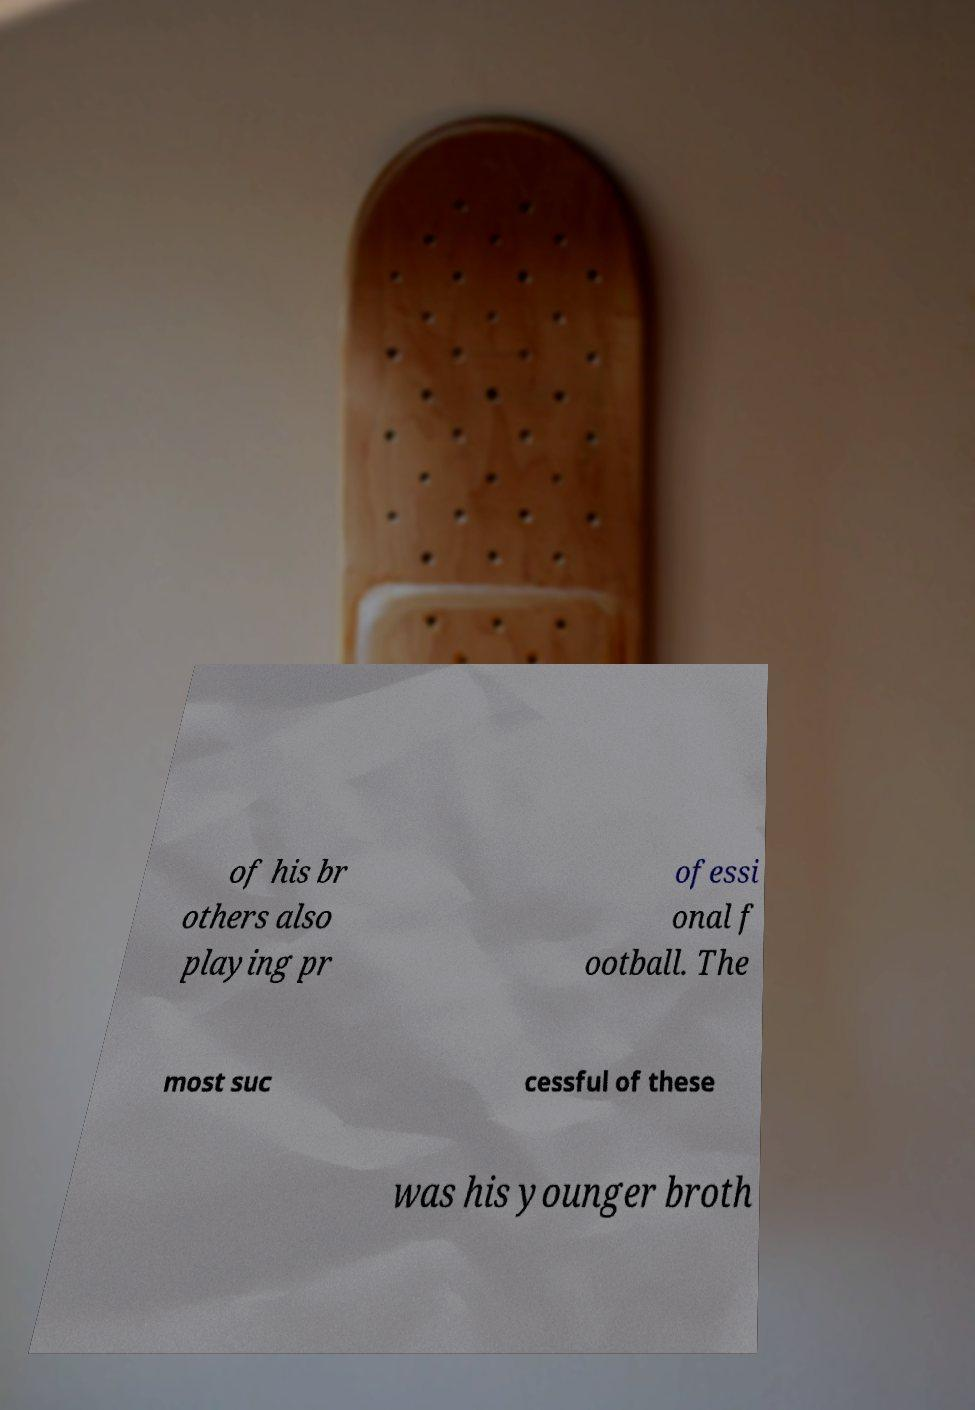Please identify and transcribe the text found in this image. of his br others also playing pr ofessi onal f ootball. The most suc cessful of these was his younger broth 